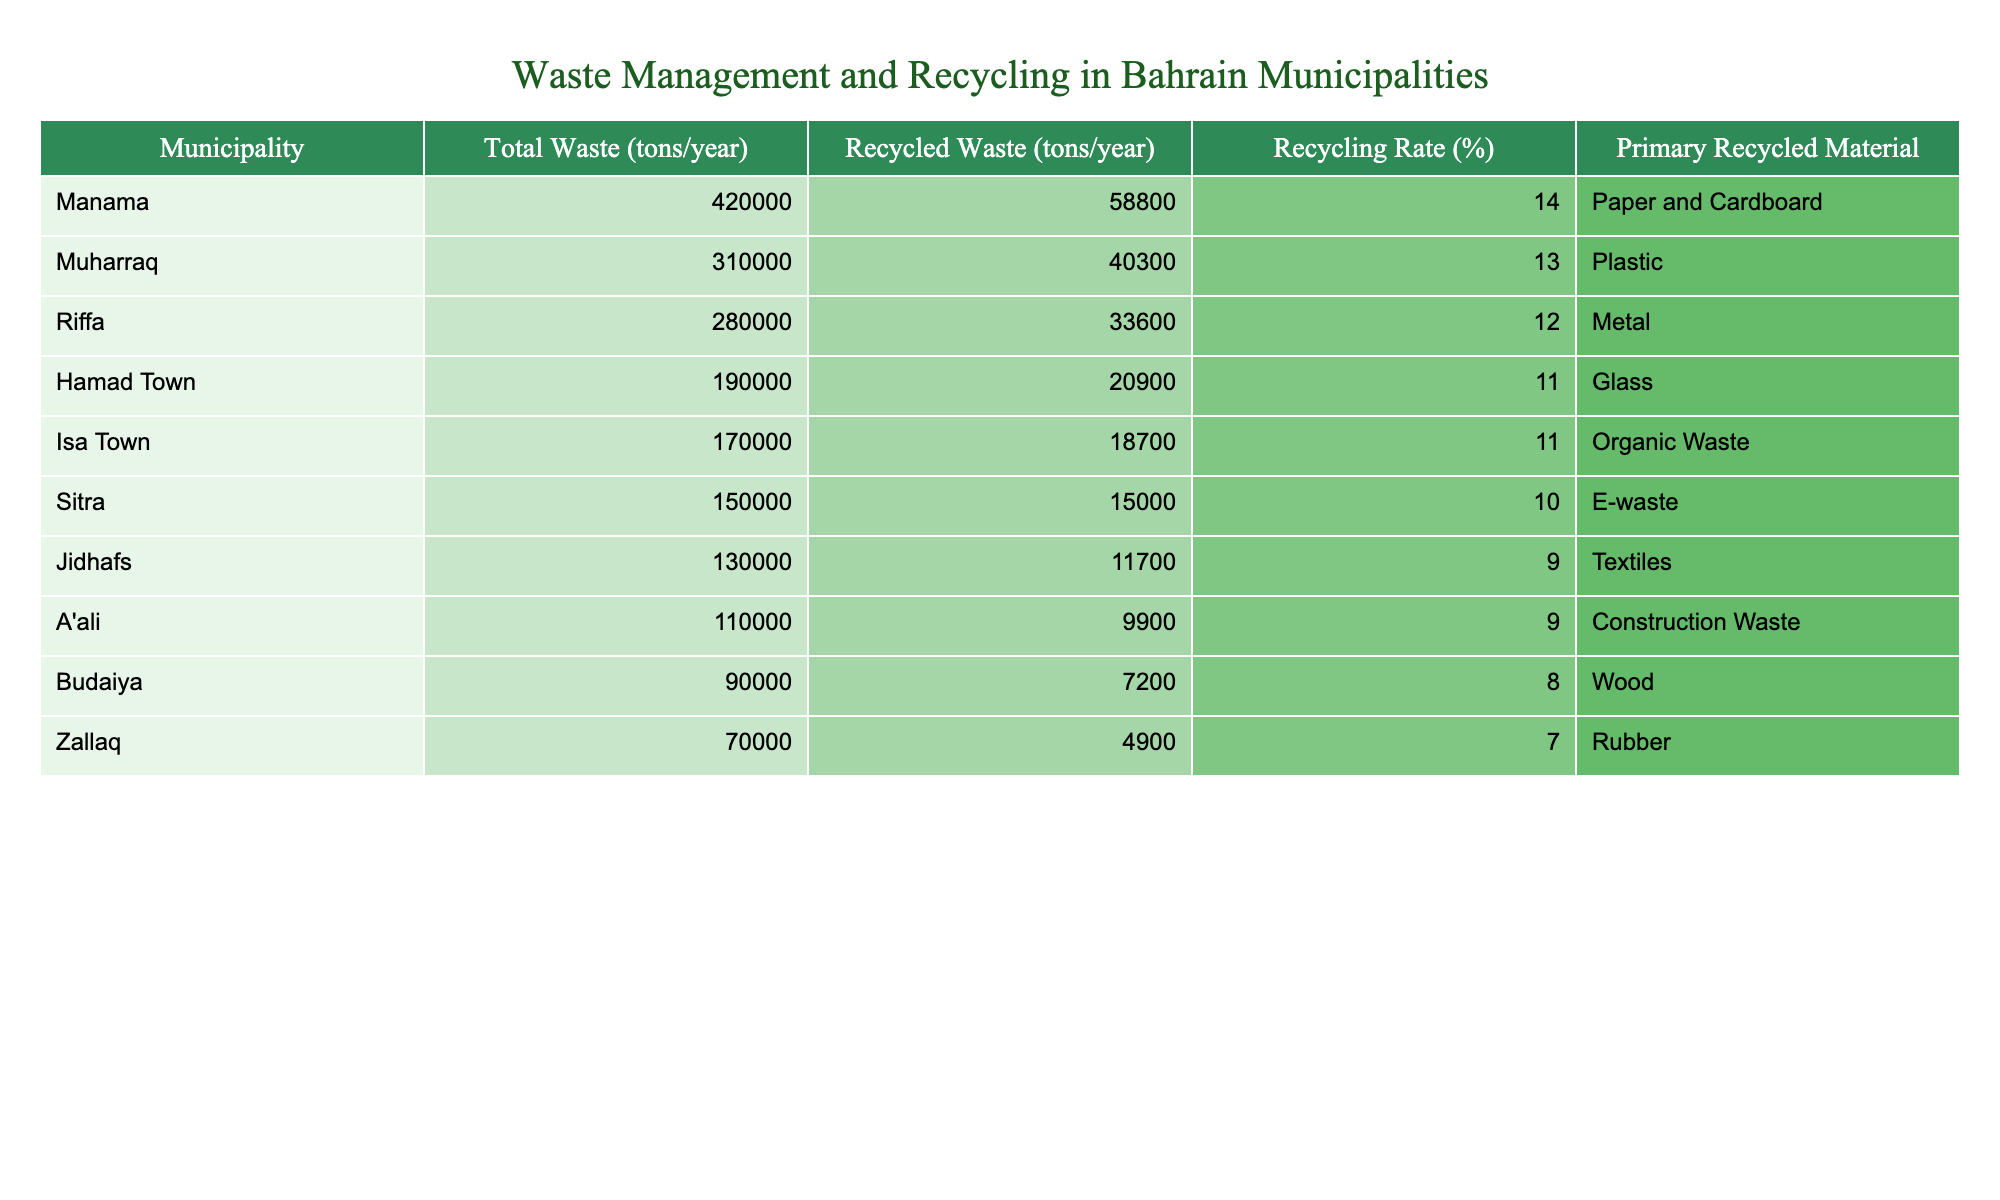What is the total waste generated in Manama? The table shows that the total waste generated in Manama is listed under the "Total Waste (tons/year)" column, which is 420,000 tons.
Answer: 420,000 tons Which municipality has the highest recycling rate? By comparing the "Recycling Rate (%)" values across all municipalities, we see that Manama has the highest recycling rate at 14%.
Answer: Manama What is the recycling rate for Isa Town? The recycling rate for Isa Town is found in the "Recycling Rate (%)" column, and it states that it is 11%.
Answer: 11% Calculate the average total waste generated by all municipalities. To find the average, we sum up the total waste for all municipalities: (420,000 + 310,000 + 280,000 + 190,000 + 170,000 + 150,000 + 130,000 + 110,000 + 90,000 + 70,000) = 1,850,000 tons. There are 10 municipalities, so the average is 1,850,000 / 10 = 185,000 tons.
Answer: 185,000 tons Does A'ali municipality have a higher recycling rate than Sitra? By looking at the respective recycling rates, A'ali has a rate of 9%, and Sitra's rate is 10%. Therefore, A'ali does not have a higher recycling rate than Sitra, as 9% is less than 10%.
Answer: No What is the total amount of recycled waste in the top three municipalities by recycling rate? The top three municipalities by recycling rate are Manama (58,800 tons), Muharraq (40,300 tons), and Riffa (33,600 tons). We sum these values: 58,800 + 40,300 + 33,600 = 132,700 tons.
Answer: 132,700 tons Which municipality primarily recycles rubber? The "Primary Recycled Material" column identifies Zallaq as the municipality that primarily recycles rubber.
Answer: Zallaq What percentage of waste is recycled in Riffa compared to Hamad Town? The recycling rate in Riffa is 12%, while Hamad Town's rate is 11%. Therefore, Riffa recycles a higher percentage of its waste compared to Hamad Town.
Answer: Yes How much more total waste is generated in Manama than in Budaiya? The total waste for Manama is 420,000 tons and for Budaiya it is 90,000 tons. The difference is 420,000 - 90,000 = 330,000 tons.
Answer: 330,000 tons Is the primary recycled material for Jidhafs textiles? The table indicates that Jidhafs recycles textiles as its primary recycled material, therefore this statement is true.
Answer: Yes What is the total recycling rate for all municipalities? The recycling rates are summed for all municipalities as follows: (14 + 13 + 12 + 11 + 11 + 10 + 9 + 9 + 8 + 7) = 93%. This value is then divided by the number of municipalities (10) to find the average, which is 93 / 10 = 9.3%.
Answer: 9.3% 